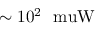<formula> <loc_0><loc_0><loc_500><loc_500>\sim 1 0 ^ { 2 } \ m u W</formula> 